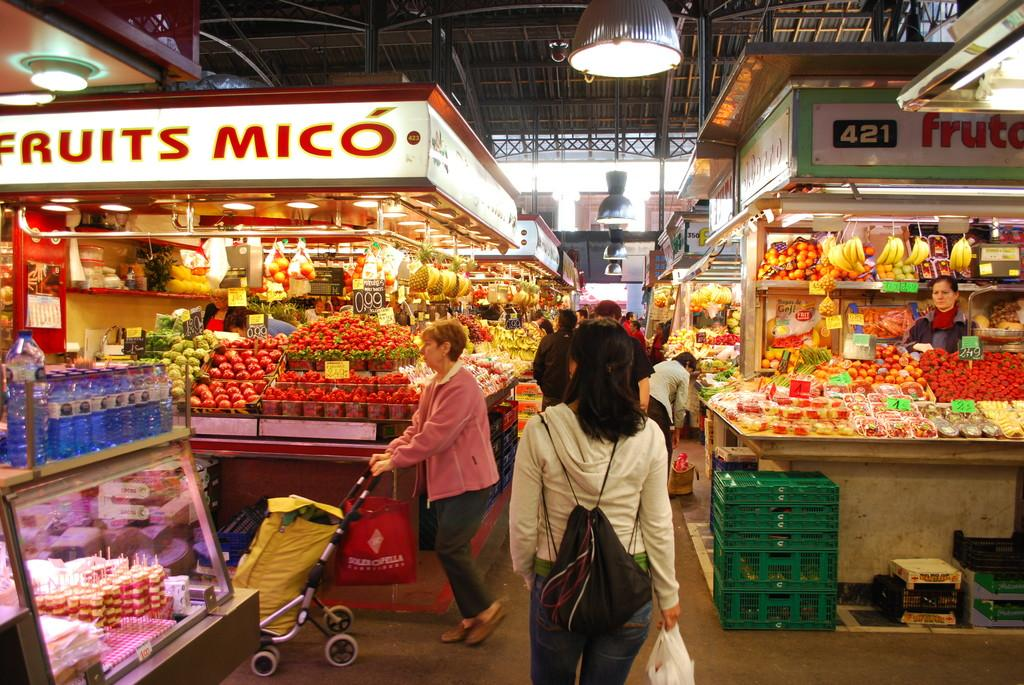<image>
Relay a brief, clear account of the picture shown. Food store with shoppers that says Fruits Mico and # 421. 